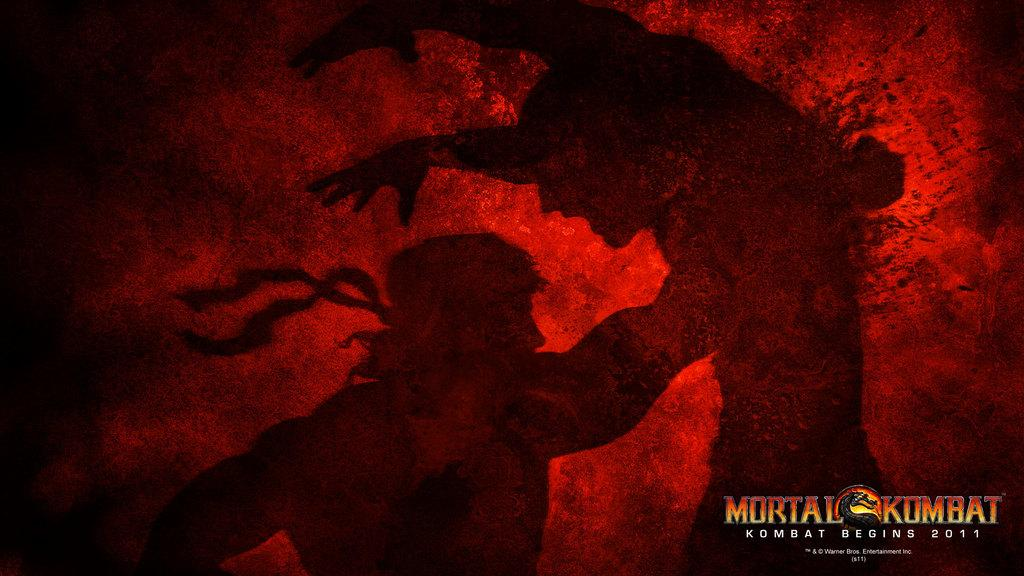<image>
Render a clear and concise summary of the photo. Poster showing two men fighting and the words "Mortal Komat" on the bottom right. 